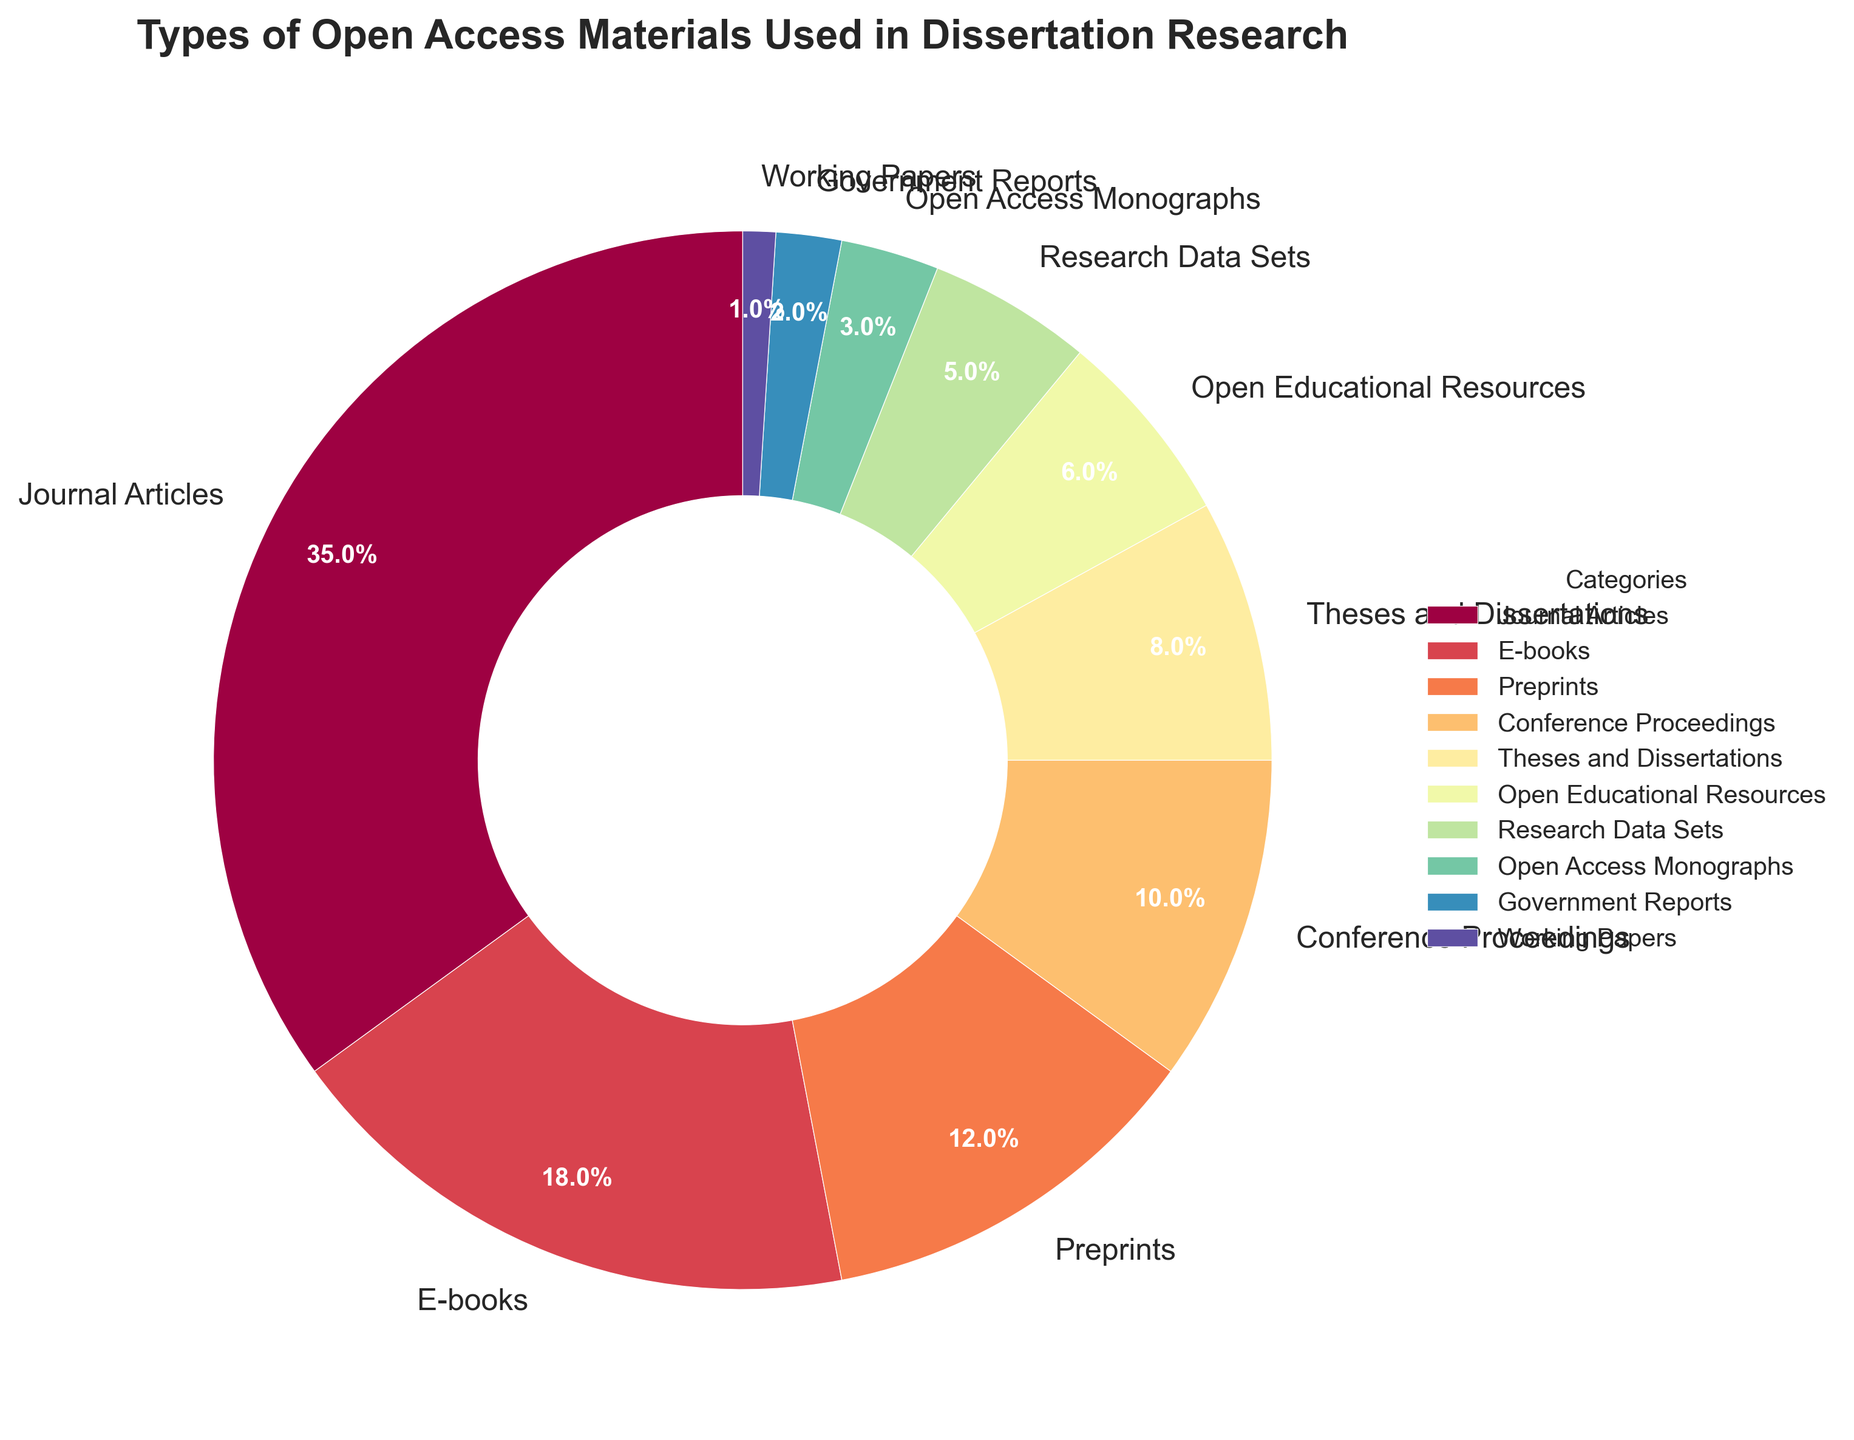Which category represents the largest percentage of open access materials used in dissertation research? The section with the largest slice in the pie chart represents the largest percentage. This is visually identifiable as the section labeled 'Journal Articles'.
Answer: Journal Articles What is the combined percentage of E-books and Preprints? Add the percentages for 'E-books' (18%) and 'Preprints' (12%). 18% + 12% = 30%
Answer: 30% Which categories account for less than 5% each? Identify categories where the percentage is less than 5%. From the chart, these are 'Research Data Sets' (5%), 'Open Access Monographs' (3%), 'Government Reports' (2%), and 'Working Papers' (1%).
Answer: Research Data Sets, Open Access Monographs, Government Reports, Working Papers How much more is the percentage of Conference Proceedings compared to Government Reports? Subtract the percentage of 'Government Reports' (2%) from that of 'Conference Proceedings' (10%). 10% - 2% = 8%
Answer: 8% What is the median percentage of all categories shown? List all percentages in ascending order: 1, 2, 3, 5, 6, 8, 10, 12, 18, 35. Since there's an even number of data points, average the 5th and 6th values: (6 + 8) / 2 = 7%
Answer: 7% Which categories together make up 52% of the materials? Sum the percentages from largest to smallest until reaching 52%: Journal Articles (35%) + E-books (18%) = 53%. This slightly exceeds 52%, so the next largest category 'Preprints' cannot be included.
Answer: Journal Articles, E-books Are there more categories with percentages above or below 10%? Count the number of categories above 10%: Journal Articles (35%), E-books (18%), Preprints (12%) = 3 categories. Count those below 10%: Conference Proceedings (10%), Theses and Dissertations (8%), Open Educational Resources (6%), Research Data Sets (5%), Open Access Monographs (3%), Government Reports (2%), Working Papers (1%) = 7 categories. There are more categories below 10%.
Answer: Below Which category’s slice is colored closest to red? Visually identify the slice on the pie chart that is colored in a hue closest to red. The pie chart legend and visual segments show 'Preprints' colored in a hue close to red.
Answer: Preprints What is the difference in percentage between Theses and Dissertations and Open Educational Resources? Subtract the percentage of 'Open Educational Resources' (6%) from 'Theses and Dissertations' (8%). 8% - 6% = 2%
Answer: 2% What percentage of the materials are not journal articles, e-books, or preprints? Sum the percentages of categories excluding Journal Articles (35%), E-books (18%), and Preprints (12%). Sum of all categories is 100%, so subtract the combined percentage of these three: 100% - (35% + 18% + 12%) = 100% - 65% = 35%
Answer: 35% 